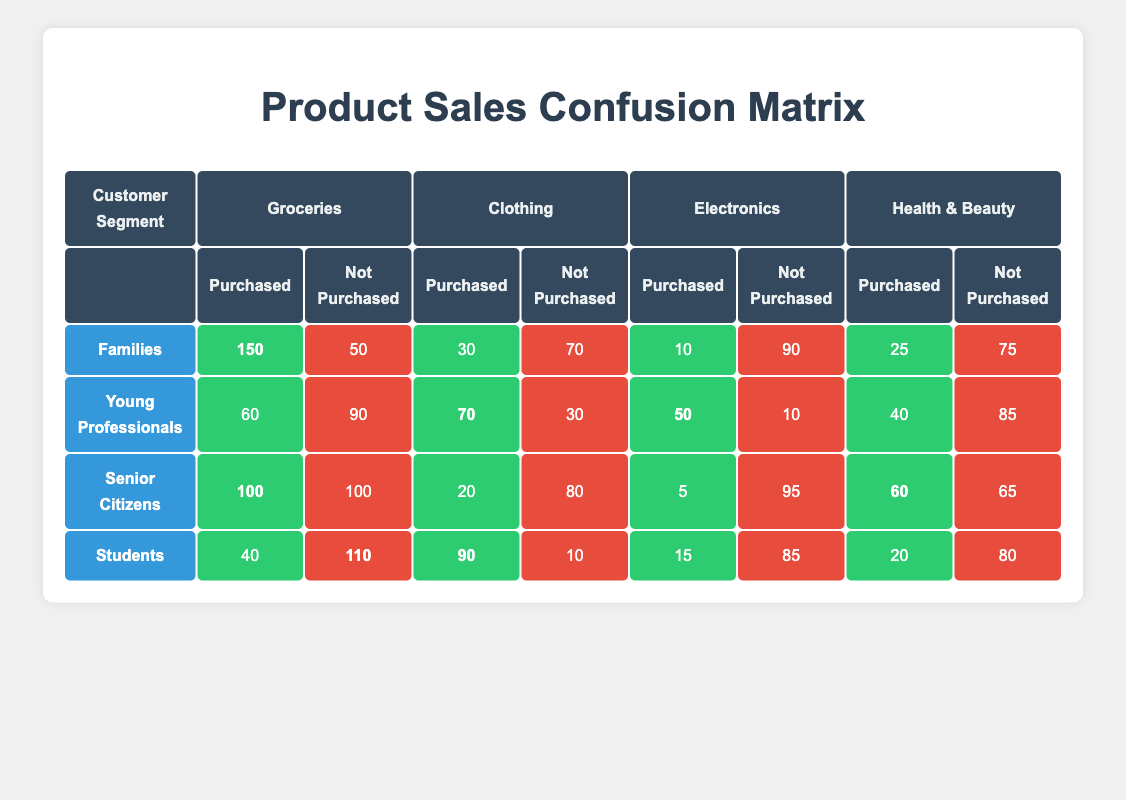What customer segment purchased the most groceries? By scanning the "Purchased" column under "Groceries," the "Families" segment had the highest value at 150 purchases.
Answer: Families Which product category did Senior Citizens purchase the least? In the "Purchased" column for "Senior Citizens," the lowest value is in "Electronics," with only 5 purchases.
Answer: Electronics What is the total number of groceries purchased across all segments? To find the total, we sum the purchased values for "Groceries": 150 (Families) + 60 (Young Professionals) + 100 (Senior Citizens) + 40 (Students) = 350.
Answer: 350 Did Young Professionals purchase more clothing than Senior Citizens? Young Professionals purchased 70 clothing items, while Senior Citizens only purchased 20. Thus, the statement is true.
Answer: Yes Which customer segment did not purchase the least amount of Health & Beauty products? The "purchased" values reveal that "Senior Citizens" bought the most Health & Beauty items at 60, so they did not purchase the least, as "Students" bought only 20.
Answer: Students What is the difference between the number of groceries purchased by Families and Students? We find the purchase values: Families purchased 150 groceries and Students purchased 40. The difference is 150 - 40 = 110.
Answer: 110 Which customer segment had the highest purchases in Health & Beauty? Looking at the "Purchased" column for "Health & Beauty," "Senior Citizens" had the highest purchase total with 60.
Answer: Senior Citizens Is it true that Students purchased more clothing than Young Professionals? Students purchased 90 clothing items while Young Professionals bought 70. Therefore, this statement is true.
Answer: Yes What is the average number of electronics purchased across all customer segments? We sum the purchased values for "Electronics": 10 (Families) + 50 (Young Professionals) + 5 (Senior Citizens) + 15 (Students) = 80. Then, dividing by the number of segments (4): 80 / 4 = 20.
Answer: 20 